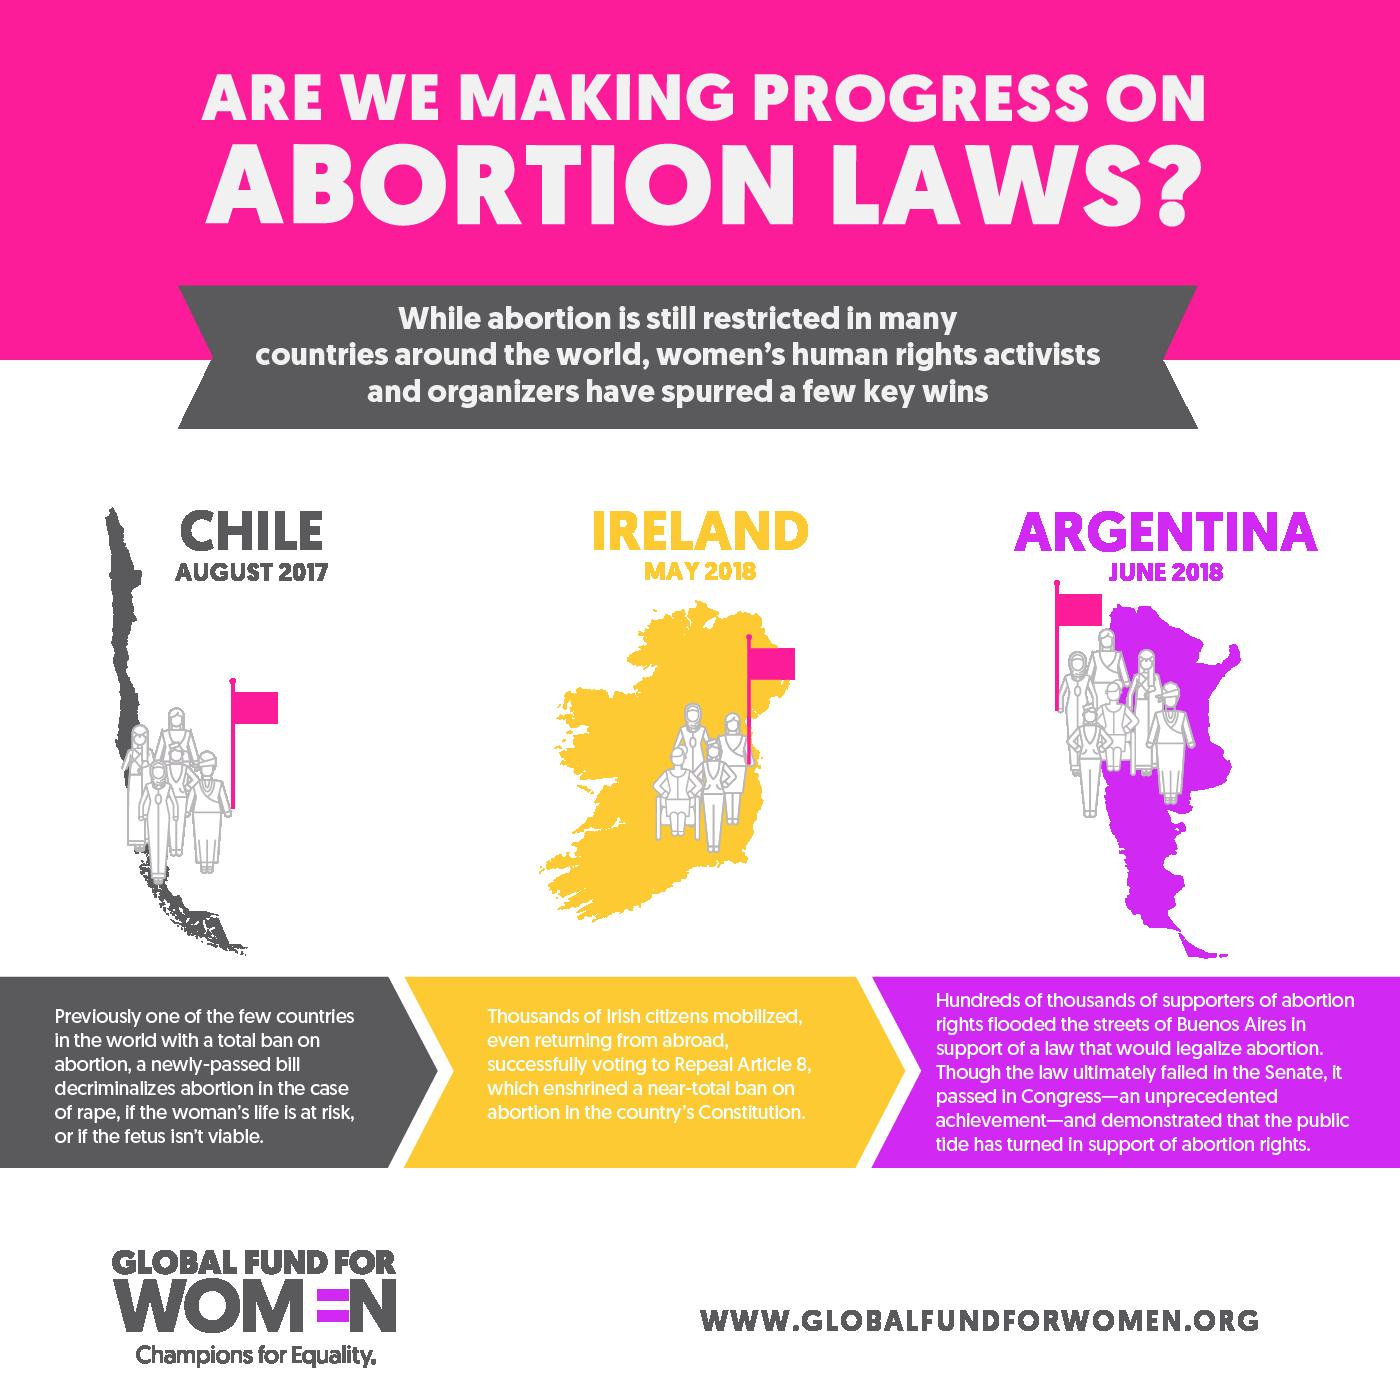Point out several critical features in this image. In May 2018, the abortion laws of Ireland were changed. On August 24, 2017, Chile became the first country in the Americas to decriminalize abortion in specific situations. In June 2018, Argentina witnessed a large public support for abortion rights, earning widespread recognition and praise for its bold and progressive stance on the issue. 